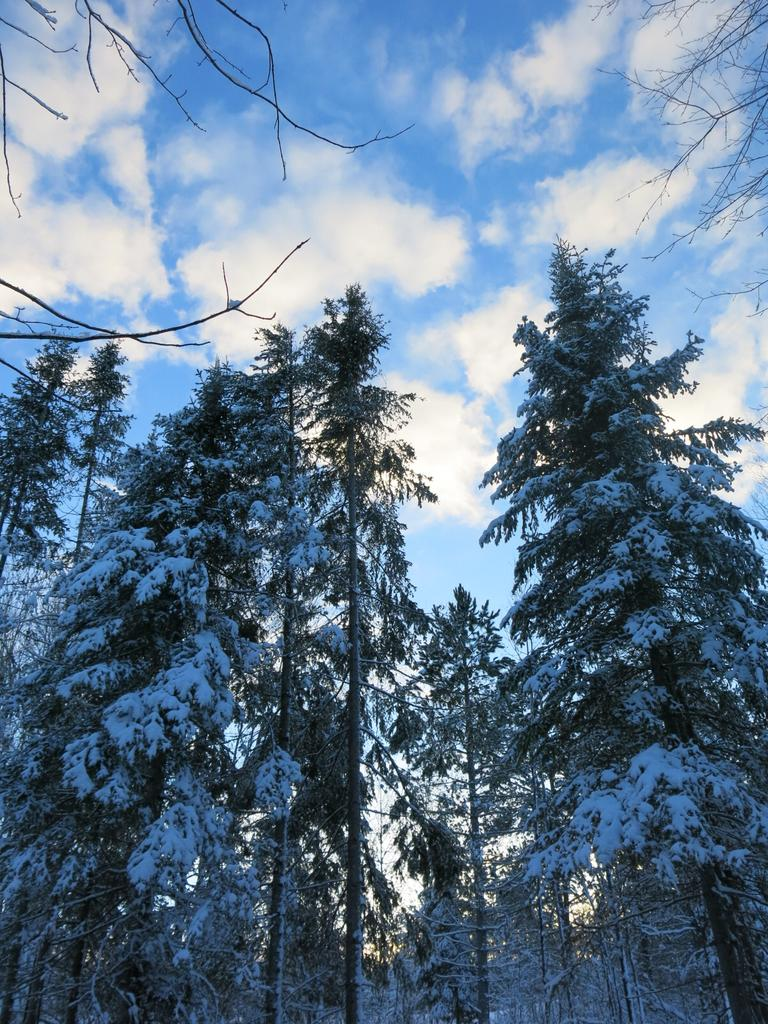What type of vegetation can be seen in the image? There are trees in the image. What is covering the trees in the image? The trees are covered with snow. What can be seen in the background of the image? There are clouds in the background of the image. What is the color of the sky in the image? The sky is blue in color. Where is the writer sitting in the image? There is no writer present in the image. What type of bomb can be seen in the image? There is no bomb present in the image. 